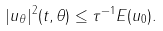Convert formula to latex. <formula><loc_0><loc_0><loc_500><loc_500>| u _ { \theta } | ^ { 2 } ( t , \theta ) \leq \tau ^ { - 1 } E ( u _ { 0 } ) .</formula> 